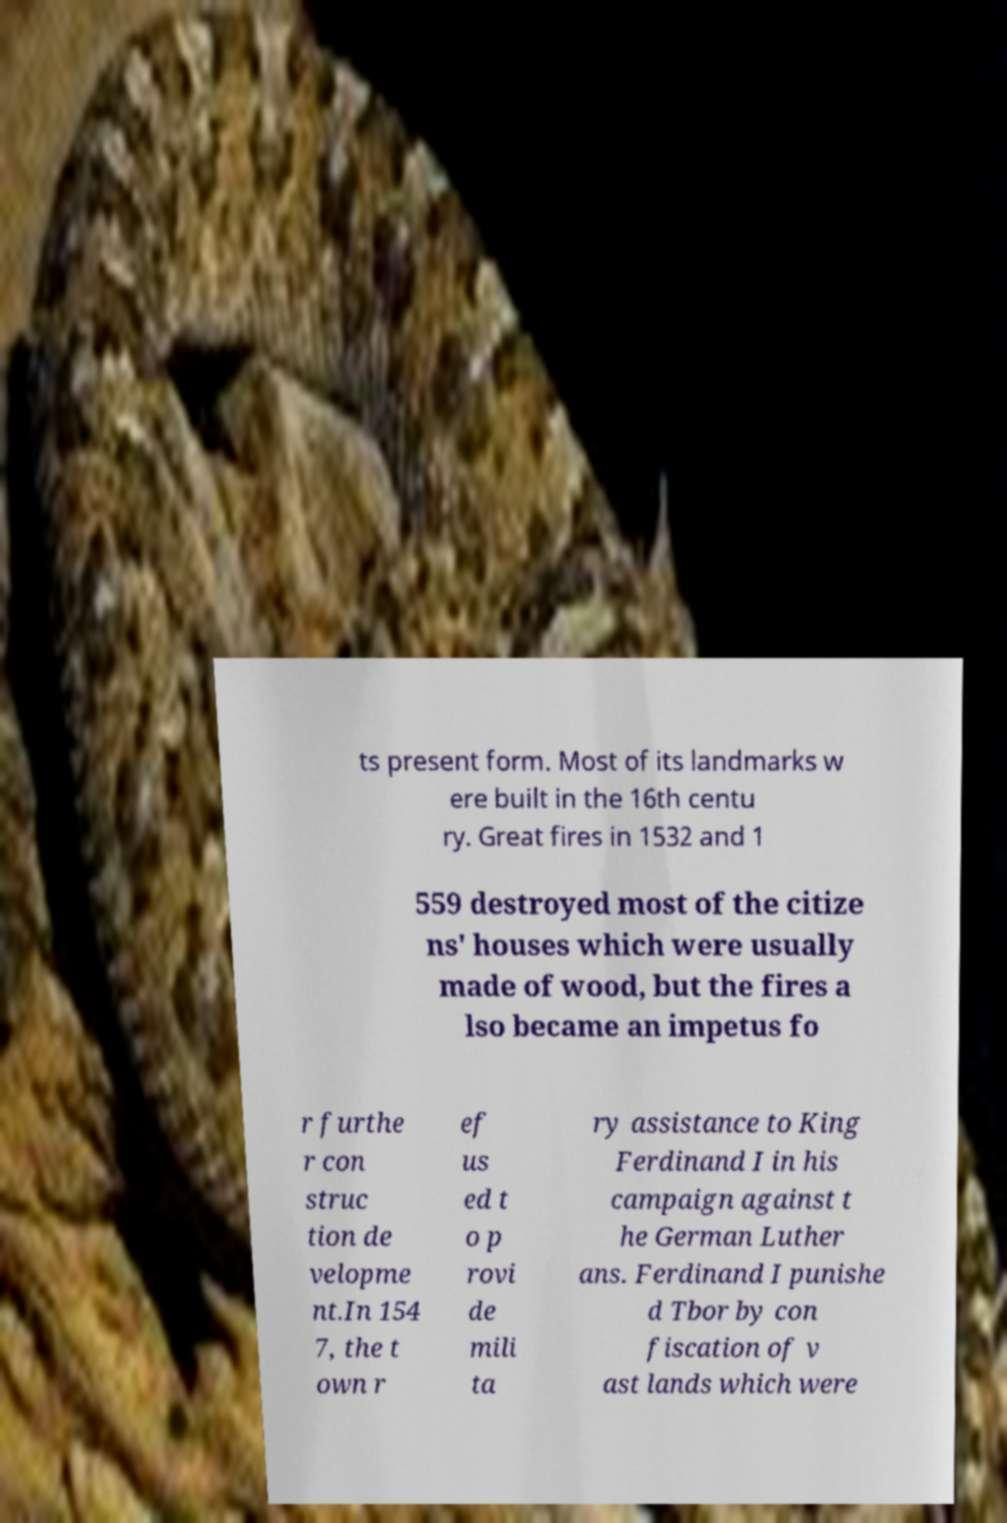Please identify and transcribe the text found in this image. ts present form. Most of its landmarks w ere built in the 16th centu ry. Great fires in 1532 and 1 559 destroyed most of the citize ns' houses which were usually made of wood, but the fires a lso became an impetus fo r furthe r con struc tion de velopme nt.In 154 7, the t own r ef us ed t o p rovi de mili ta ry assistance to King Ferdinand I in his campaign against t he German Luther ans. Ferdinand I punishe d Tbor by con fiscation of v ast lands which were 